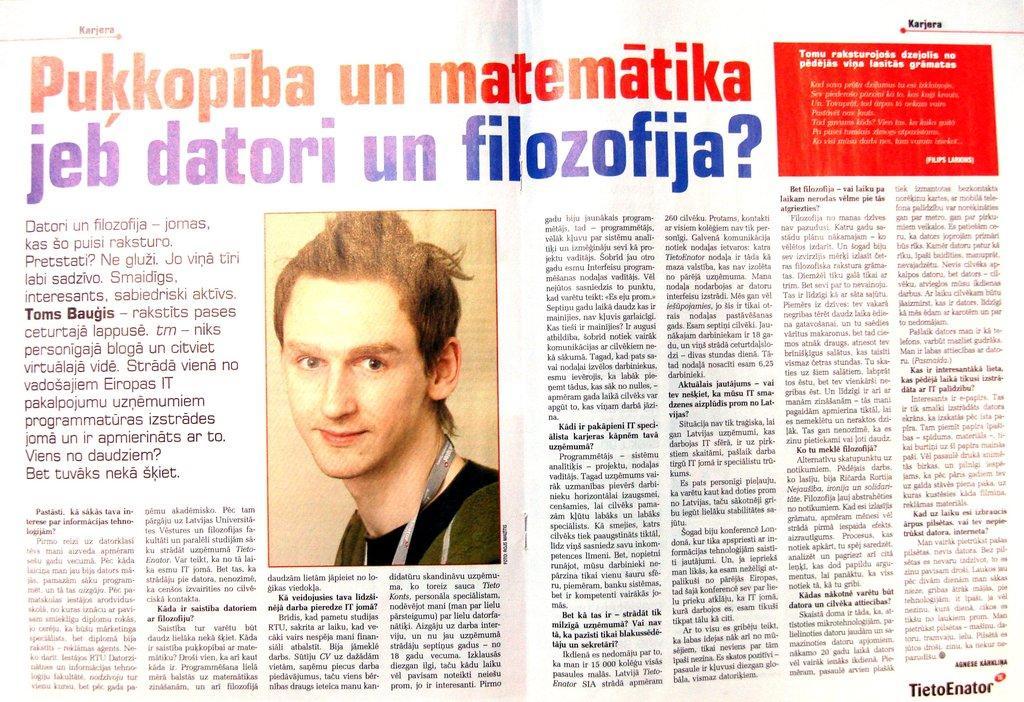Describe this image in one or two sentences. In this picture, we see the photo of the man and the text written in the book. At the top, we see the highlighted text written in red and blue color. In the right bottom, it is red in color and we some text written on it. 